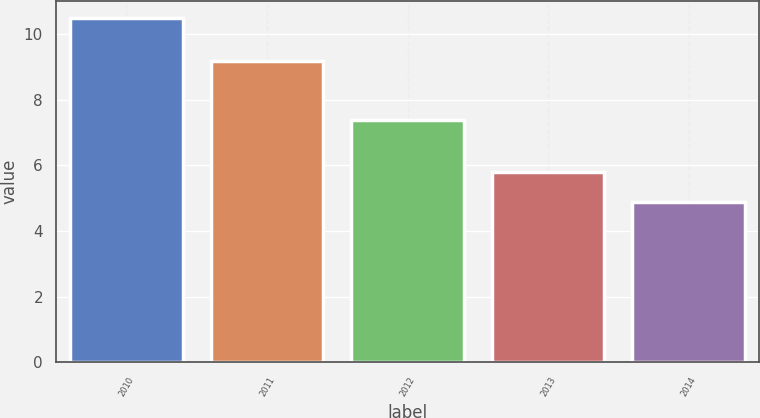<chart> <loc_0><loc_0><loc_500><loc_500><bar_chart><fcel>2010<fcel>2011<fcel>2012<fcel>2013<fcel>2014<nl><fcel>10.5<fcel>9.2<fcel>7.4<fcel>5.8<fcel>4.9<nl></chart> 